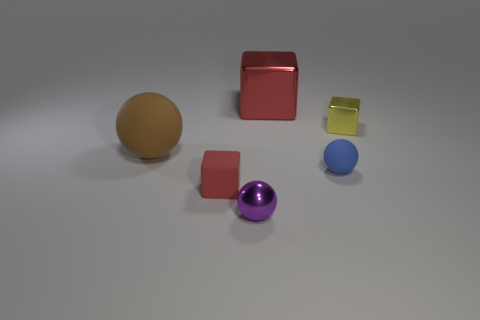What number of tiny objects are yellow blocks or purple metal spheres?
Give a very brief answer. 2. There is another red object that is the same shape as the small red rubber object; what material is it?
Provide a succinct answer. Metal. Is there anything else that is the same material as the purple thing?
Ensure brevity in your answer.  Yes. What color is the big sphere?
Your response must be concise. Brown. Do the large metallic cube and the large sphere have the same color?
Your answer should be very brief. No. What number of objects are on the left side of the tiny block that is in front of the brown matte object?
Provide a short and direct response. 1. What is the size of the object that is to the left of the small purple object and behind the small blue object?
Offer a very short reply. Large. What is the block that is in front of the yellow object made of?
Keep it short and to the point. Rubber. Are there any other tiny metallic objects that have the same shape as the yellow object?
Ensure brevity in your answer.  No. What number of tiny red objects are the same shape as the brown thing?
Offer a very short reply. 0. 